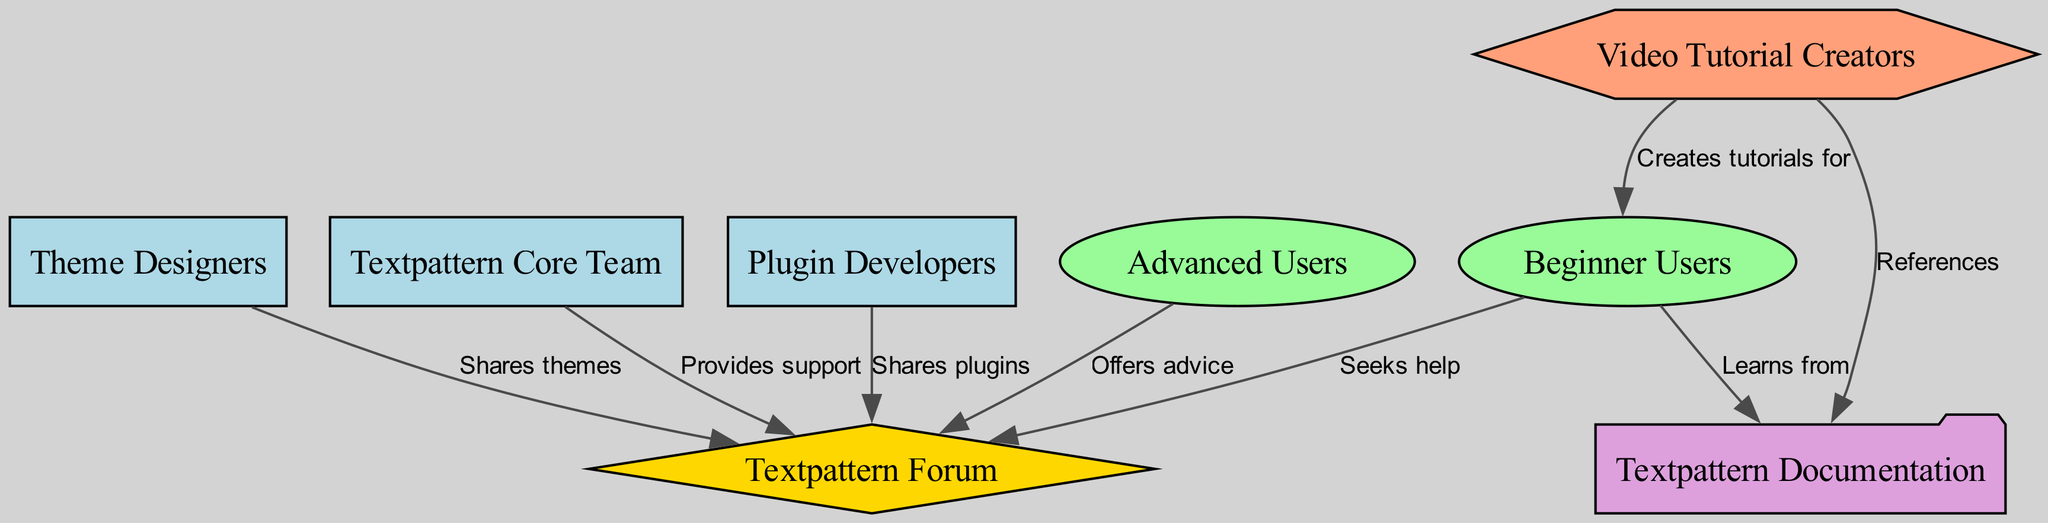What is the label of node 1? Node 1 in the diagram is labeled as "Textpattern Core Team". This is explicitly stated in the node data provided.
Answer: Textpattern Core Team How many types of developers are represented in the diagram? The diagram shows three types of developers: "Textpattern Core Team", "Plugin Developers", and "Theme Designers". Counting these gives a total of 3 distinct types.
Answer: 3 What type of node is "Textpattern Forum"? "Textpattern Forum" is classified as a community type in the diagram. This can be verified by reviewing the node and type information.
Answer: community What relationship exists between "Video Tutorial Creators" and "Beginner Users"? "Video Tutorial Creators" create tutorials for "Beginner Users", which is directly indicated by the edge label connecting these two nodes.
Answer: Creates tutorials for How many edges connect to "Textpattern Documentation"? "Textpattern Documentation" connects to two nodes: "Video Tutorial Creators" (which references it) and "Beginner Users" (which learns from it). Hence, there are 2 edges connecting to it.
Answer: 2 What does the "Theme Designers" contribute to the community? "Theme Designers" shares themes with the "Textpattern Forum". This is indicated by the edge label connecting "Theme Designers" and "Textpattern Forum".
Answer: Shares themes Which user type seeks help from the community? The "Beginner Users" node is specified to seek help from the "Textpattern Forum", as shown by the corresponding edge label in the diagram.
Answer: Beginner Users How many nodes are there in total? The diagram contains a total of 8 nodes, as listed in the data under the nodes section.
Answer: 8 Which type of node is represented by "Textpattern Core Team"? "Textpattern Core Team" is categorized as a developer in the diagram, based on its type classification.
Answer: developer 